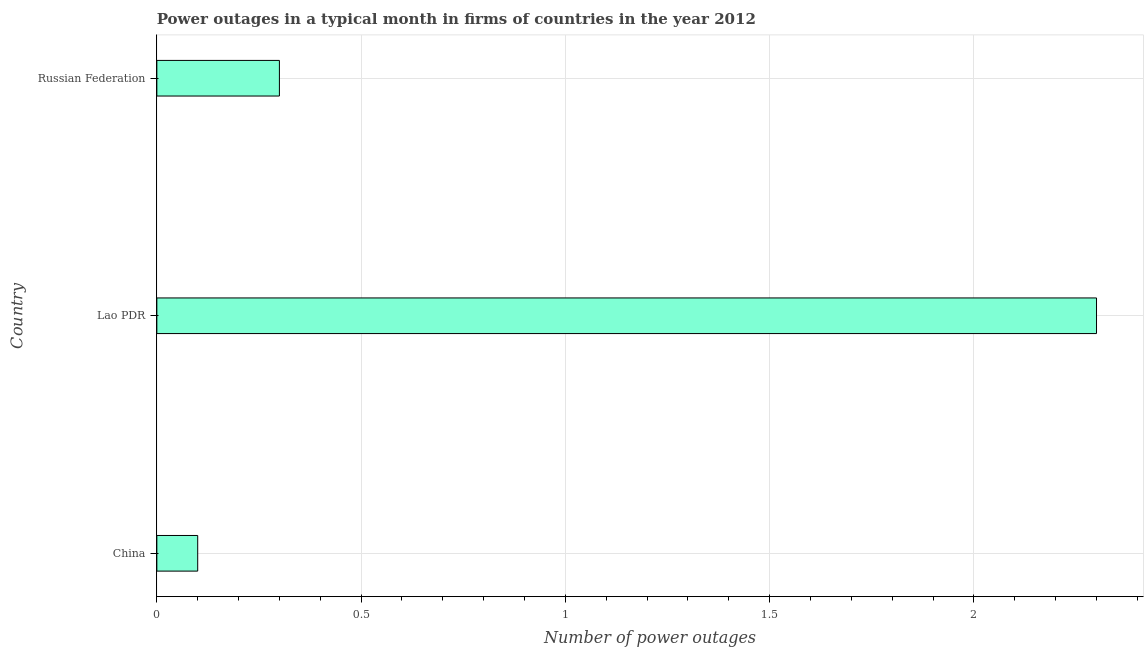Does the graph contain any zero values?
Offer a terse response. No. Does the graph contain grids?
Offer a terse response. Yes. What is the title of the graph?
Your answer should be very brief. Power outages in a typical month in firms of countries in the year 2012. What is the label or title of the X-axis?
Ensure brevity in your answer.  Number of power outages. What is the label or title of the Y-axis?
Provide a succinct answer. Country. What is the number of power outages in Lao PDR?
Your answer should be compact. 2.3. Across all countries, what is the maximum number of power outages?
Provide a short and direct response. 2.3. In which country was the number of power outages maximum?
Offer a very short reply. Lao PDR. In which country was the number of power outages minimum?
Make the answer very short. China. What is the sum of the number of power outages?
Your answer should be very brief. 2.7. What is the average number of power outages per country?
Provide a succinct answer. 0.9. What is the ratio of the number of power outages in China to that in Russian Federation?
Keep it short and to the point. 0.33. Is the difference between the number of power outages in China and Lao PDR greater than the difference between any two countries?
Your response must be concise. Yes. In how many countries, is the number of power outages greater than the average number of power outages taken over all countries?
Keep it short and to the point. 1. What is the difference between two consecutive major ticks on the X-axis?
Your answer should be compact. 0.5. What is the Number of power outages of Lao PDR?
Give a very brief answer. 2.3. What is the difference between the Number of power outages in China and Lao PDR?
Offer a very short reply. -2.2. What is the difference between the Number of power outages in Lao PDR and Russian Federation?
Your response must be concise. 2. What is the ratio of the Number of power outages in China to that in Lao PDR?
Keep it short and to the point. 0.04. What is the ratio of the Number of power outages in China to that in Russian Federation?
Your answer should be compact. 0.33. What is the ratio of the Number of power outages in Lao PDR to that in Russian Federation?
Make the answer very short. 7.67. 